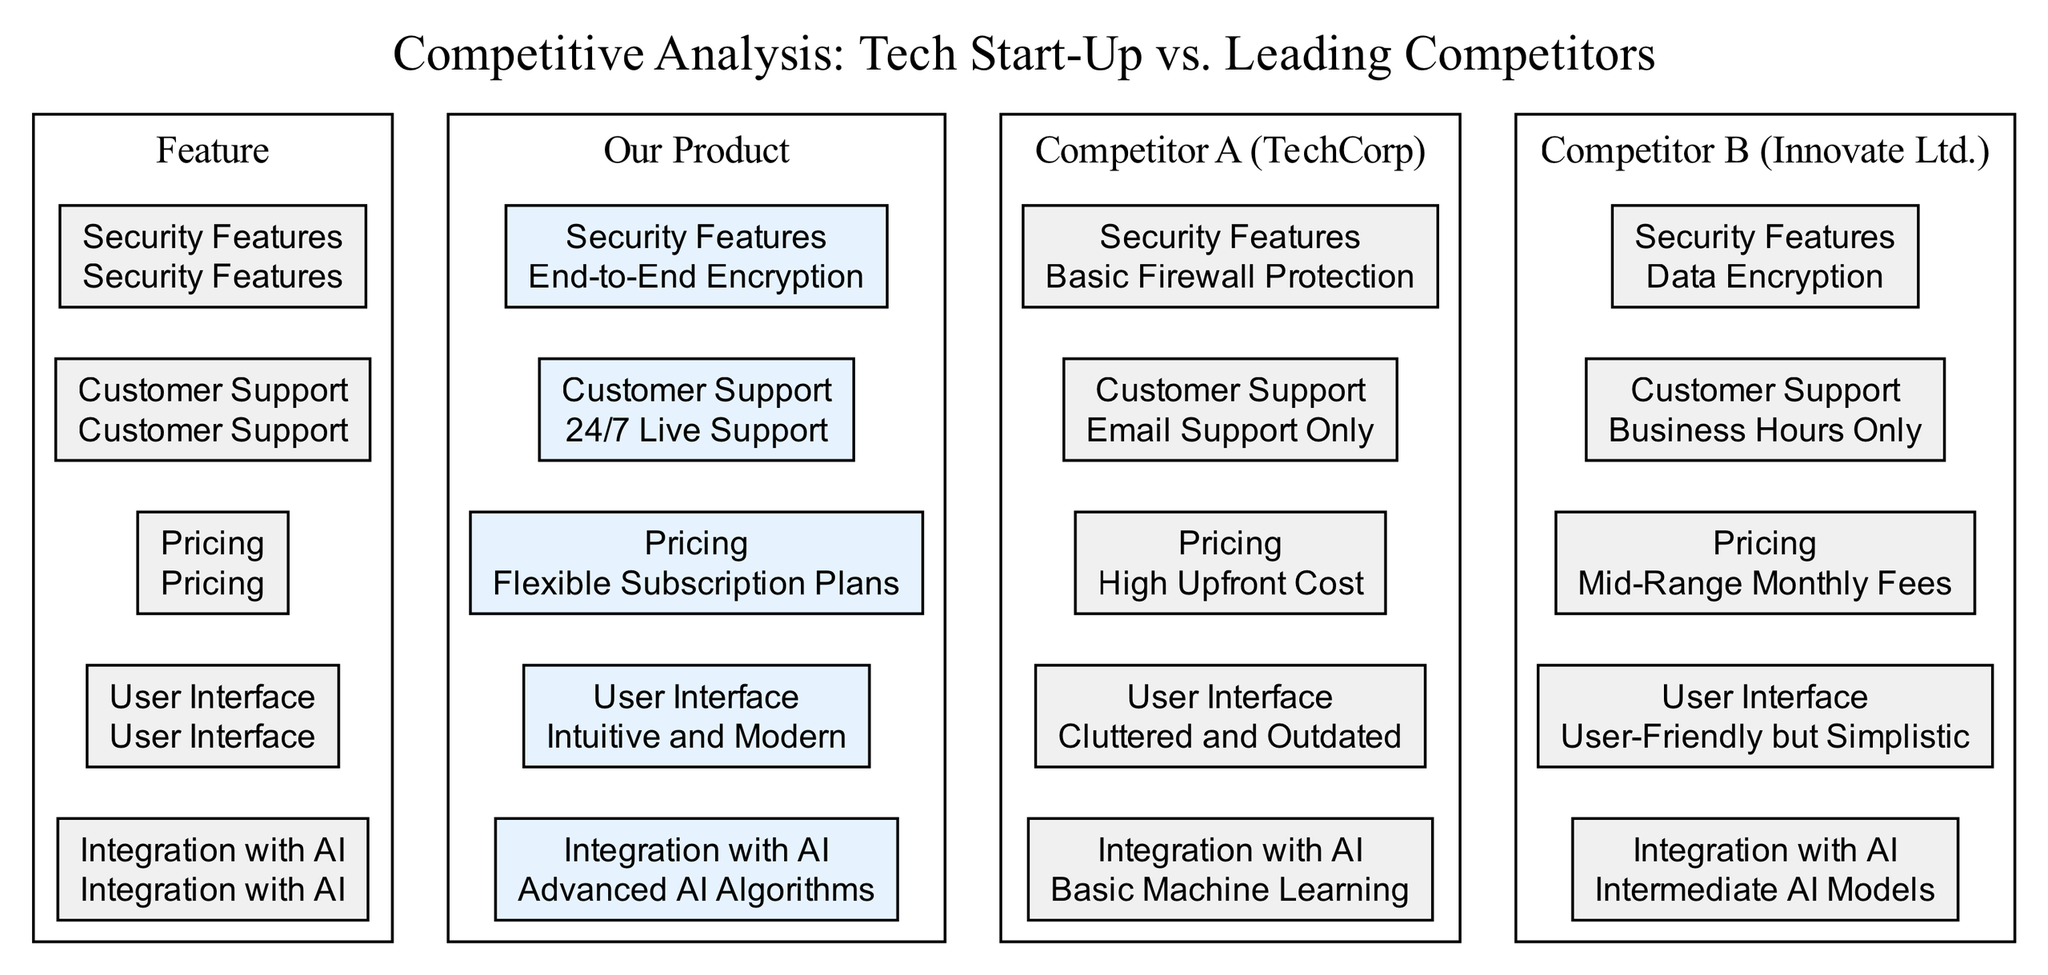What feature offers advanced technology in our product? The diagram shows "Integration with AI" as a feature where "Our Product" has "Advanced AI Algorithms", indicating it offers advanced technology in this area.
Answer: Advanced AI Algorithms Which competitor has the highest customer support availability? According to the diagram, "Our Product" offers "24/7 Live Support", while both competitors have more limited support options, making ours the highest in availability.
Answer: 24/7 Live Support What is the pricing strategy for Competitor A? The diagram specifically states that "Competitor A" has a "High Upfront Cost" for pricing, which is the key takeaway when comparing pricing strategies.
Answer: High Upfront Cost How does our user interface compare to Competitor B? The diagram indicates that "Our Product" features an "Intuitive and Modern" user interface, while "Competitor B" has a "User-Friendly but Simplistic" user interface, suggesting ours is more advanced.
Answer: Intuitive and Modern Which product has stronger security features? The diagram shows that "Our Product" has "End-to-End Encryption", while Competitor A has "Basic Firewall Protection" and Competitor B has "Data Encryption", indicating ours is stronger.
Answer: End-to-End Encryption What do all competitors lack compared to our product in terms of customer support? Analyzing customer support options, both competitors offer limited support: "Competitor A" provides "Email Support Only" and "Competitor B" offers "Business Hours Only", while we provide 24/7 assistance, highlighting our advantage.
Answer: 24/7 Live Support Which feature does Competitor B only have at an intermediate level? The diagram points out that "Competitor B" has "Intermediate AI Models" under "Integration with AI," indicating that this feature is not as robust in comparison to others.
Answer: Intermediate AI Models What monthly pricing strategy does Competitor B follow? The diagram elaborates that "Competitor B" has "Mid-Range Monthly Fees" as their pricing strategy, which is a key differentiation compared to ours.
Answer: Mid-Range Monthly Fees Which product is noted for a cluttered user interface? The diagram specifically mentions that "Competitor A" has a "Cluttered and Outdated" user interface, indicating it is less appealing to users compared to others.
Answer: Cluttered and Outdated What is a common drawback among the competitor's security features? By examining the diagram, it shows that both "Competitor A" and "Competitor B" have less comprehensive security features: "Basic Firewall Protection" and "Data Encryption" respectively, which are inadequate compared to "End-to-End Encryption".
Answer: Basic Firewall Protection and Data Encryption 